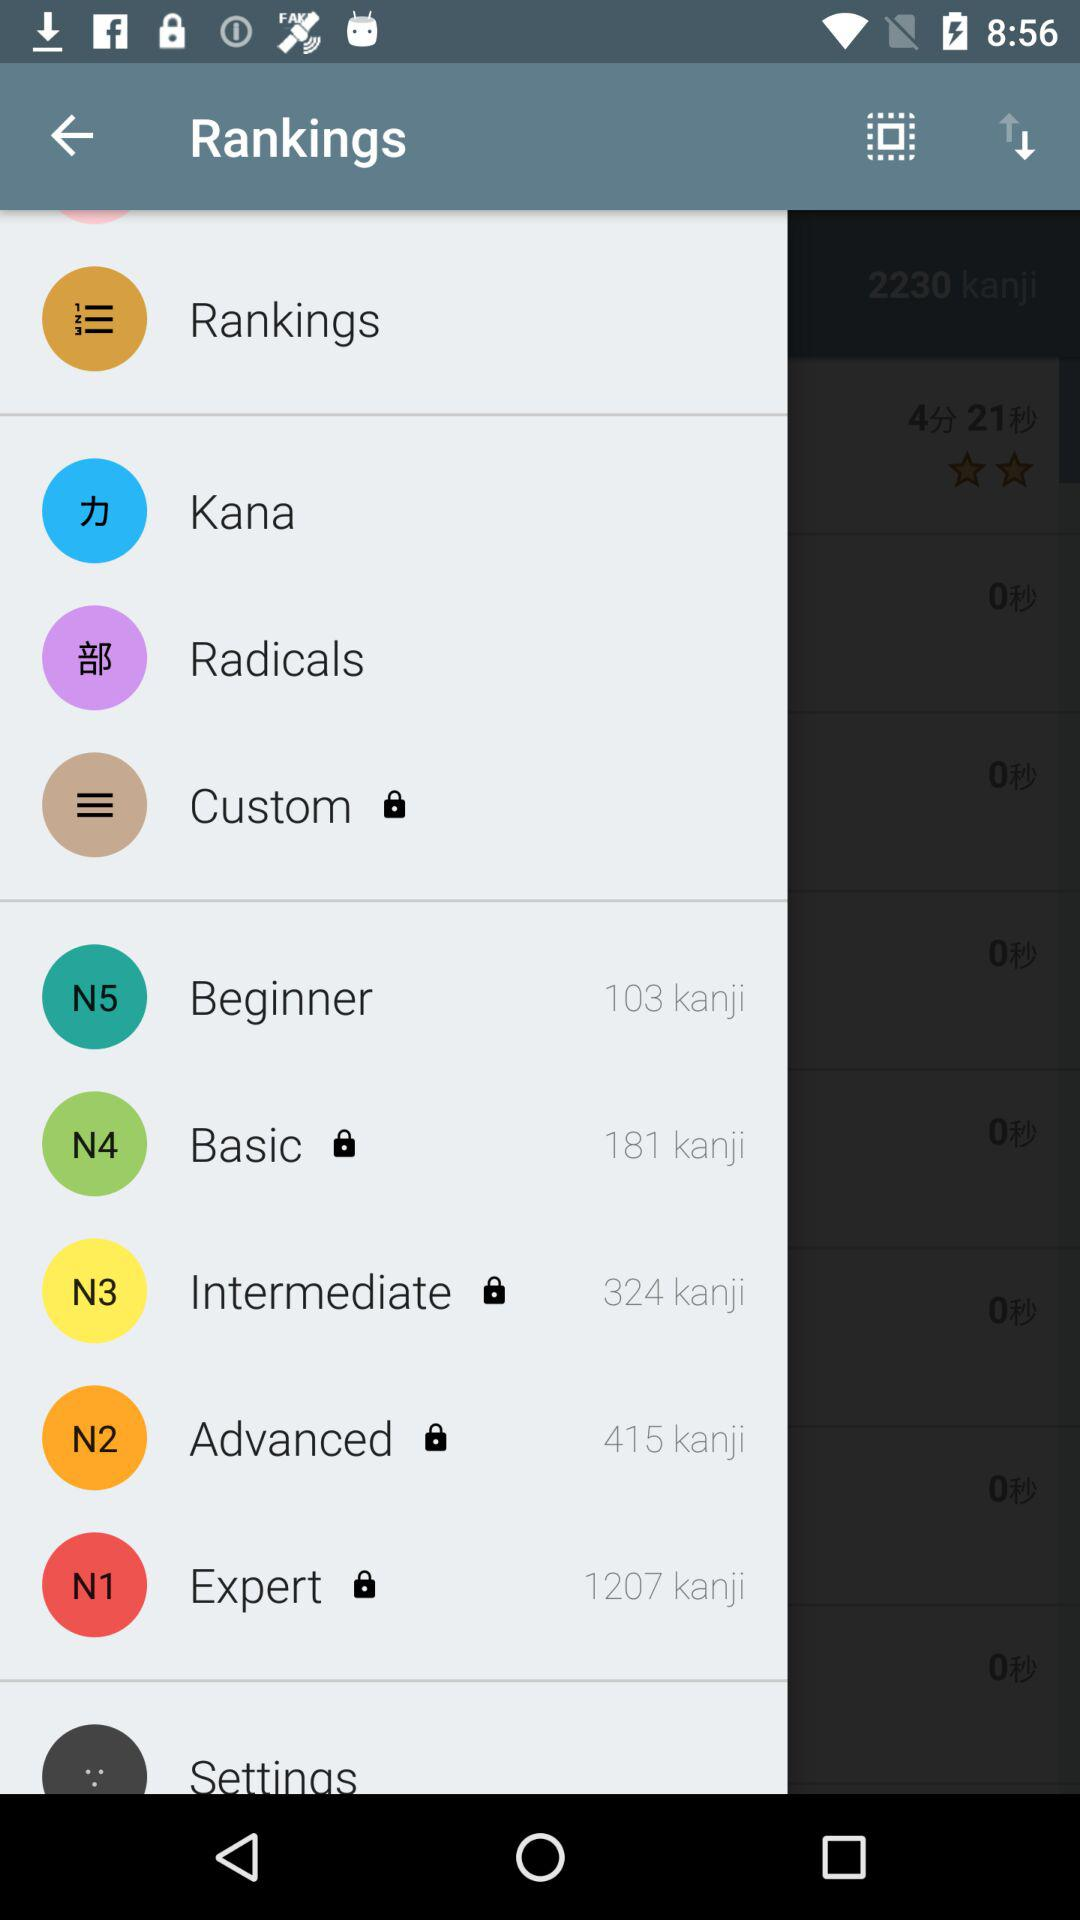What is the count of kanji in "Intermediate"? The count of kanji is 324. 